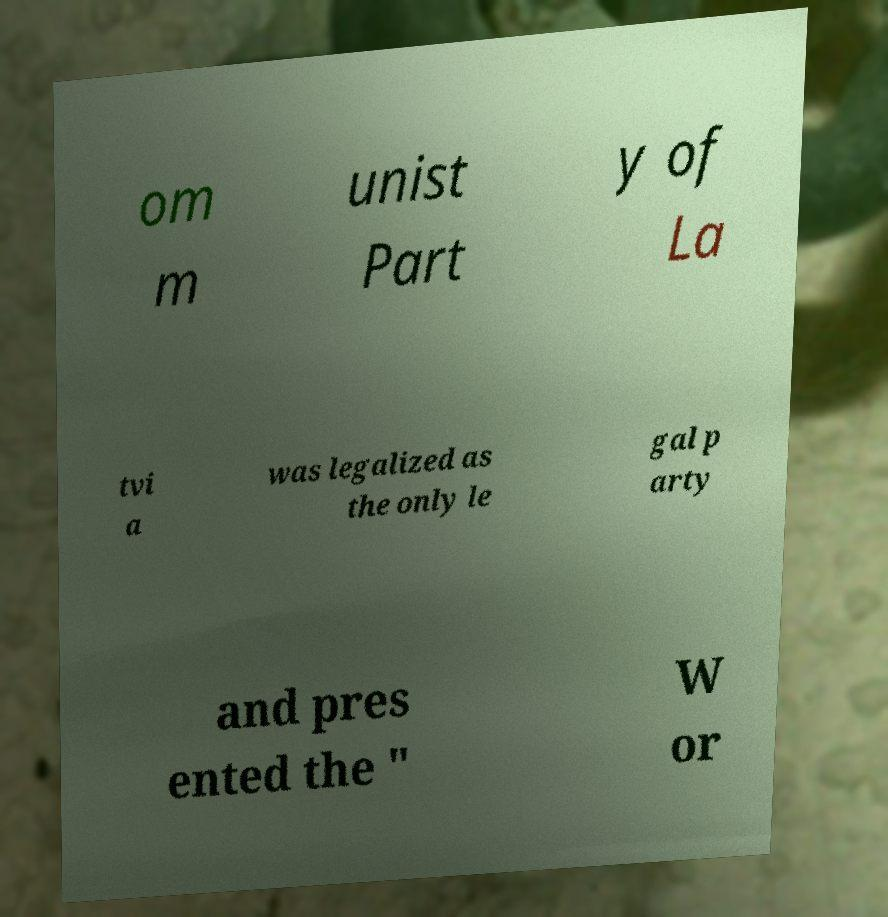Please identify and transcribe the text found in this image. om m unist Part y of La tvi a was legalized as the only le gal p arty and pres ented the " W or 